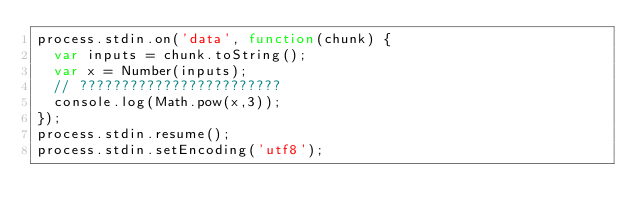<code> <loc_0><loc_0><loc_500><loc_500><_JavaScript_>process.stdin.on('data', function(chunk) {
  var inputs = chunk.toString();
  var x = Number(inputs);
  // ????????????????????????
  console.log(Math.pow(x,3));
});
process.stdin.resume();
process.stdin.setEncoding('utf8');</code> 